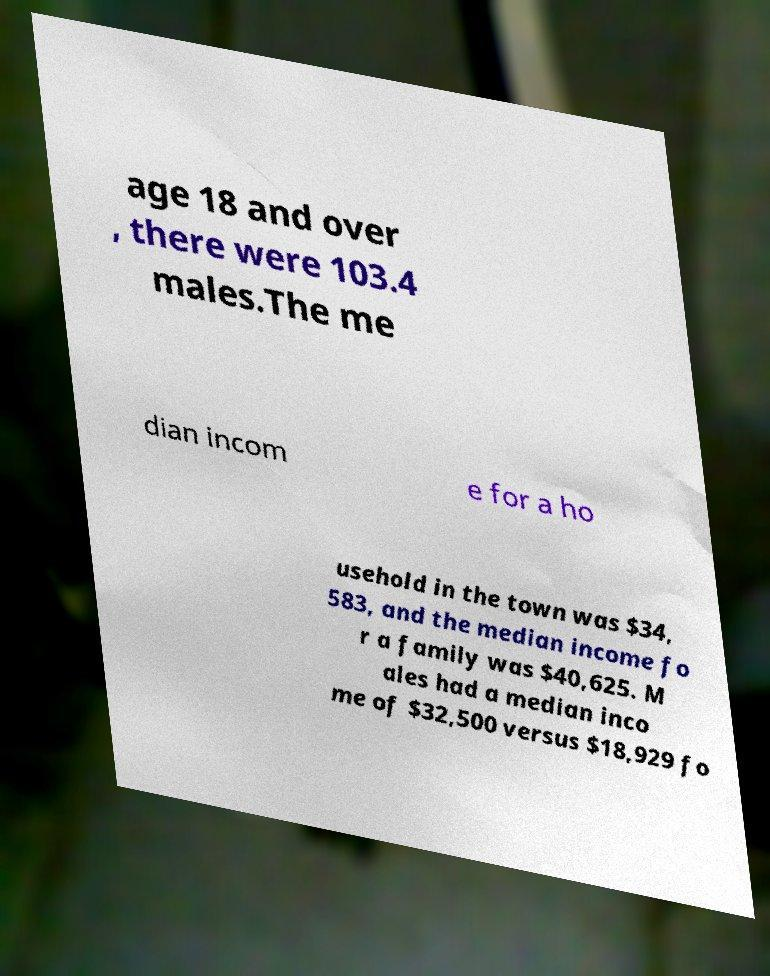Can you accurately transcribe the text from the provided image for me? age 18 and over , there were 103.4 males.The me dian incom e for a ho usehold in the town was $34, 583, and the median income fo r a family was $40,625. M ales had a median inco me of $32,500 versus $18,929 fo 